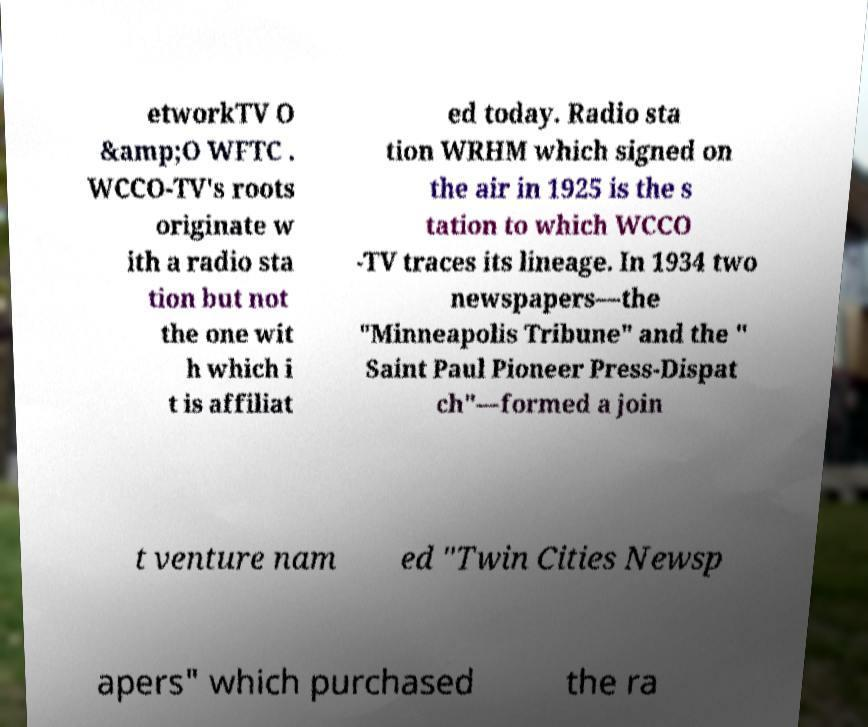Please identify and transcribe the text found in this image. etworkTV O &amp;O WFTC . WCCO-TV's roots originate w ith a radio sta tion but not the one wit h which i t is affiliat ed today. Radio sta tion WRHM which signed on the air in 1925 is the s tation to which WCCO -TV traces its lineage. In 1934 two newspapers—the "Minneapolis Tribune" and the " Saint Paul Pioneer Press-Dispat ch"—formed a join t venture nam ed "Twin Cities Newsp apers" which purchased the ra 